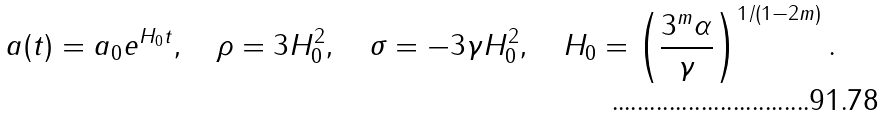<formula> <loc_0><loc_0><loc_500><loc_500>a ( t ) = a _ { 0 } e ^ { H _ { 0 } t } , \quad \rho = 3 H _ { 0 } ^ { 2 } , \quad \sigma = - 3 \gamma H _ { 0 } ^ { 2 } , \quad H _ { 0 } = \left ( \frac { 3 ^ { m } \alpha } { \gamma } \right ) ^ { 1 / ( 1 - 2 m ) } .</formula> 